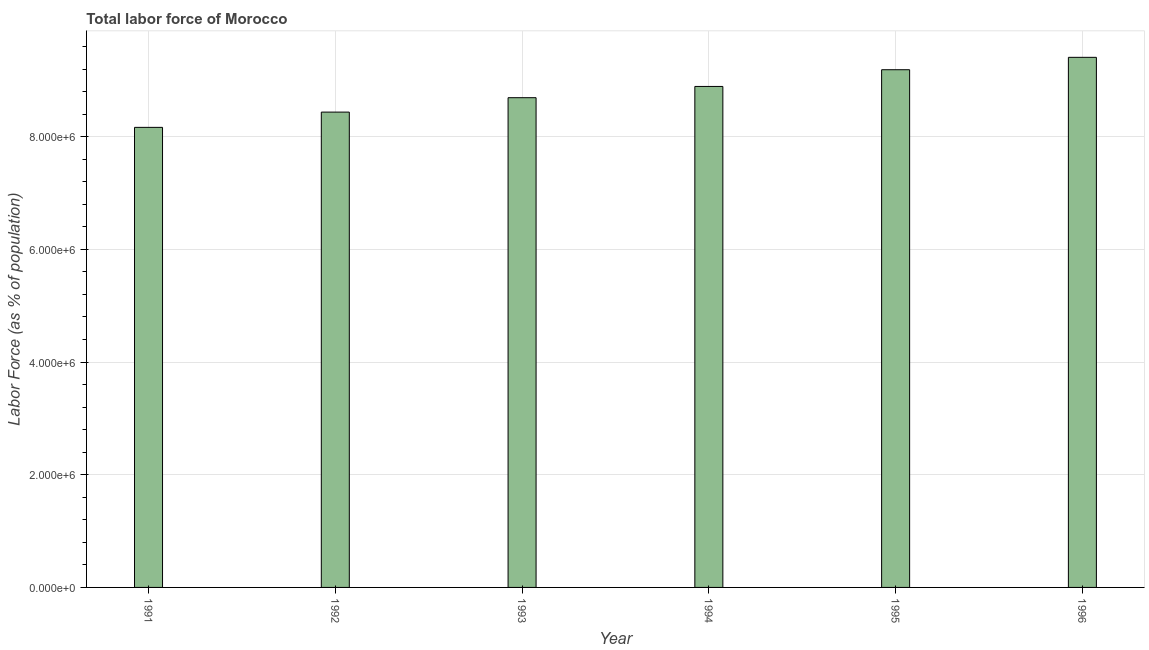Does the graph contain grids?
Make the answer very short. Yes. What is the title of the graph?
Your response must be concise. Total labor force of Morocco. What is the label or title of the Y-axis?
Offer a very short reply. Labor Force (as % of population). What is the total labor force in 1993?
Offer a terse response. 8.69e+06. Across all years, what is the maximum total labor force?
Provide a short and direct response. 9.41e+06. Across all years, what is the minimum total labor force?
Offer a terse response. 8.16e+06. In which year was the total labor force minimum?
Provide a succinct answer. 1991. What is the sum of the total labor force?
Your response must be concise. 5.28e+07. What is the difference between the total labor force in 1991 and 1995?
Give a very brief answer. -1.02e+06. What is the average total labor force per year?
Ensure brevity in your answer.  8.80e+06. What is the median total labor force?
Ensure brevity in your answer.  8.79e+06. In how many years, is the total labor force greater than 7200000 %?
Your response must be concise. 6. Do a majority of the years between 1995 and 1994 (inclusive) have total labor force greater than 7200000 %?
Offer a terse response. No. Is the total labor force in 1991 less than that in 1993?
Make the answer very short. Yes. What is the difference between the highest and the second highest total labor force?
Your answer should be very brief. 2.20e+05. What is the difference between the highest and the lowest total labor force?
Ensure brevity in your answer.  1.24e+06. How many bars are there?
Give a very brief answer. 6. Are all the bars in the graph horizontal?
Ensure brevity in your answer.  No. How many years are there in the graph?
Your answer should be very brief. 6. What is the difference between two consecutive major ticks on the Y-axis?
Provide a short and direct response. 2.00e+06. What is the Labor Force (as % of population) of 1991?
Your response must be concise. 8.16e+06. What is the Labor Force (as % of population) in 1992?
Make the answer very short. 8.44e+06. What is the Labor Force (as % of population) in 1993?
Provide a succinct answer. 8.69e+06. What is the Labor Force (as % of population) of 1994?
Offer a terse response. 8.89e+06. What is the Labor Force (as % of population) in 1995?
Make the answer very short. 9.19e+06. What is the Labor Force (as % of population) of 1996?
Provide a short and direct response. 9.41e+06. What is the difference between the Labor Force (as % of population) in 1991 and 1992?
Make the answer very short. -2.71e+05. What is the difference between the Labor Force (as % of population) in 1991 and 1993?
Your answer should be compact. -5.27e+05. What is the difference between the Labor Force (as % of population) in 1991 and 1994?
Your answer should be compact. -7.26e+05. What is the difference between the Labor Force (as % of population) in 1991 and 1995?
Make the answer very short. -1.02e+06. What is the difference between the Labor Force (as % of population) in 1991 and 1996?
Make the answer very short. -1.24e+06. What is the difference between the Labor Force (as % of population) in 1992 and 1993?
Give a very brief answer. -2.56e+05. What is the difference between the Labor Force (as % of population) in 1992 and 1994?
Your answer should be compact. -4.55e+05. What is the difference between the Labor Force (as % of population) in 1992 and 1995?
Your answer should be compact. -7.52e+05. What is the difference between the Labor Force (as % of population) in 1992 and 1996?
Provide a succinct answer. -9.72e+05. What is the difference between the Labor Force (as % of population) in 1993 and 1994?
Your response must be concise. -2.00e+05. What is the difference between the Labor Force (as % of population) in 1993 and 1995?
Make the answer very short. -4.97e+05. What is the difference between the Labor Force (as % of population) in 1993 and 1996?
Ensure brevity in your answer.  -7.16e+05. What is the difference between the Labor Force (as % of population) in 1994 and 1995?
Your answer should be very brief. -2.97e+05. What is the difference between the Labor Force (as % of population) in 1994 and 1996?
Provide a succinct answer. -5.17e+05. What is the difference between the Labor Force (as % of population) in 1995 and 1996?
Provide a succinct answer. -2.20e+05. What is the ratio of the Labor Force (as % of population) in 1991 to that in 1993?
Ensure brevity in your answer.  0.94. What is the ratio of the Labor Force (as % of population) in 1991 to that in 1994?
Provide a succinct answer. 0.92. What is the ratio of the Labor Force (as % of population) in 1991 to that in 1995?
Offer a very short reply. 0.89. What is the ratio of the Labor Force (as % of population) in 1991 to that in 1996?
Ensure brevity in your answer.  0.87. What is the ratio of the Labor Force (as % of population) in 1992 to that in 1993?
Offer a very short reply. 0.97. What is the ratio of the Labor Force (as % of population) in 1992 to that in 1994?
Make the answer very short. 0.95. What is the ratio of the Labor Force (as % of population) in 1992 to that in 1995?
Your answer should be compact. 0.92. What is the ratio of the Labor Force (as % of population) in 1992 to that in 1996?
Make the answer very short. 0.9. What is the ratio of the Labor Force (as % of population) in 1993 to that in 1994?
Your answer should be compact. 0.98. What is the ratio of the Labor Force (as % of population) in 1993 to that in 1995?
Offer a very short reply. 0.95. What is the ratio of the Labor Force (as % of population) in 1993 to that in 1996?
Give a very brief answer. 0.92. What is the ratio of the Labor Force (as % of population) in 1994 to that in 1995?
Offer a very short reply. 0.97. What is the ratio of the Labor Force (as % of population) in 1994 to that in 1996?
Your answer should be very brief. 0.94. 